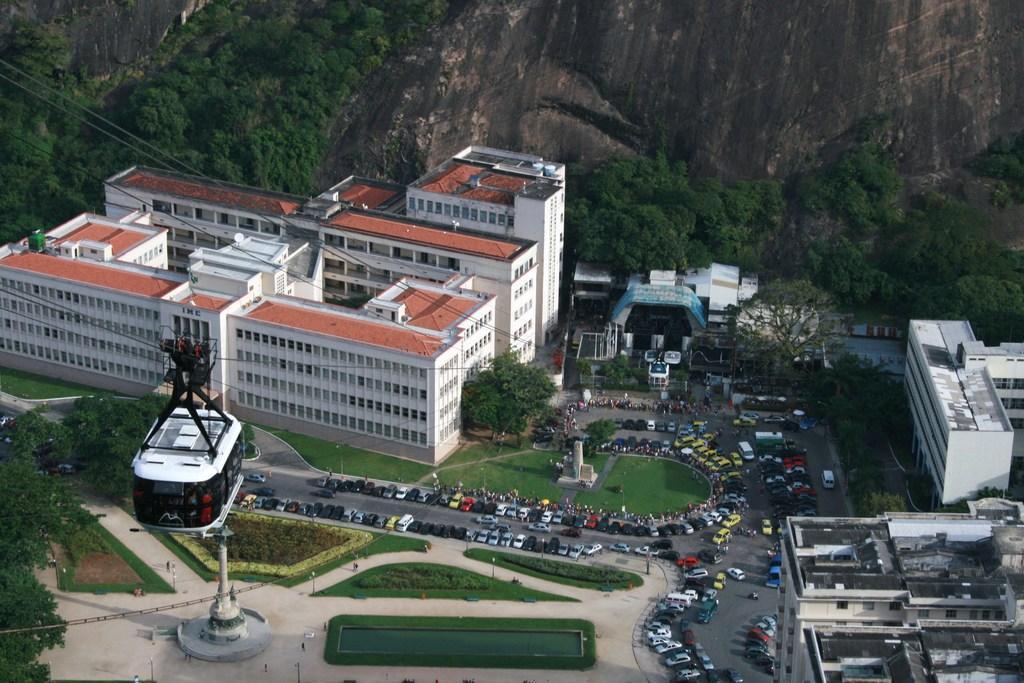Could you give a brief overview of what you see in this image? In this image we can see trees, hills, buildings, ropeway, cables, fountain, motor vehicles, water and road. 